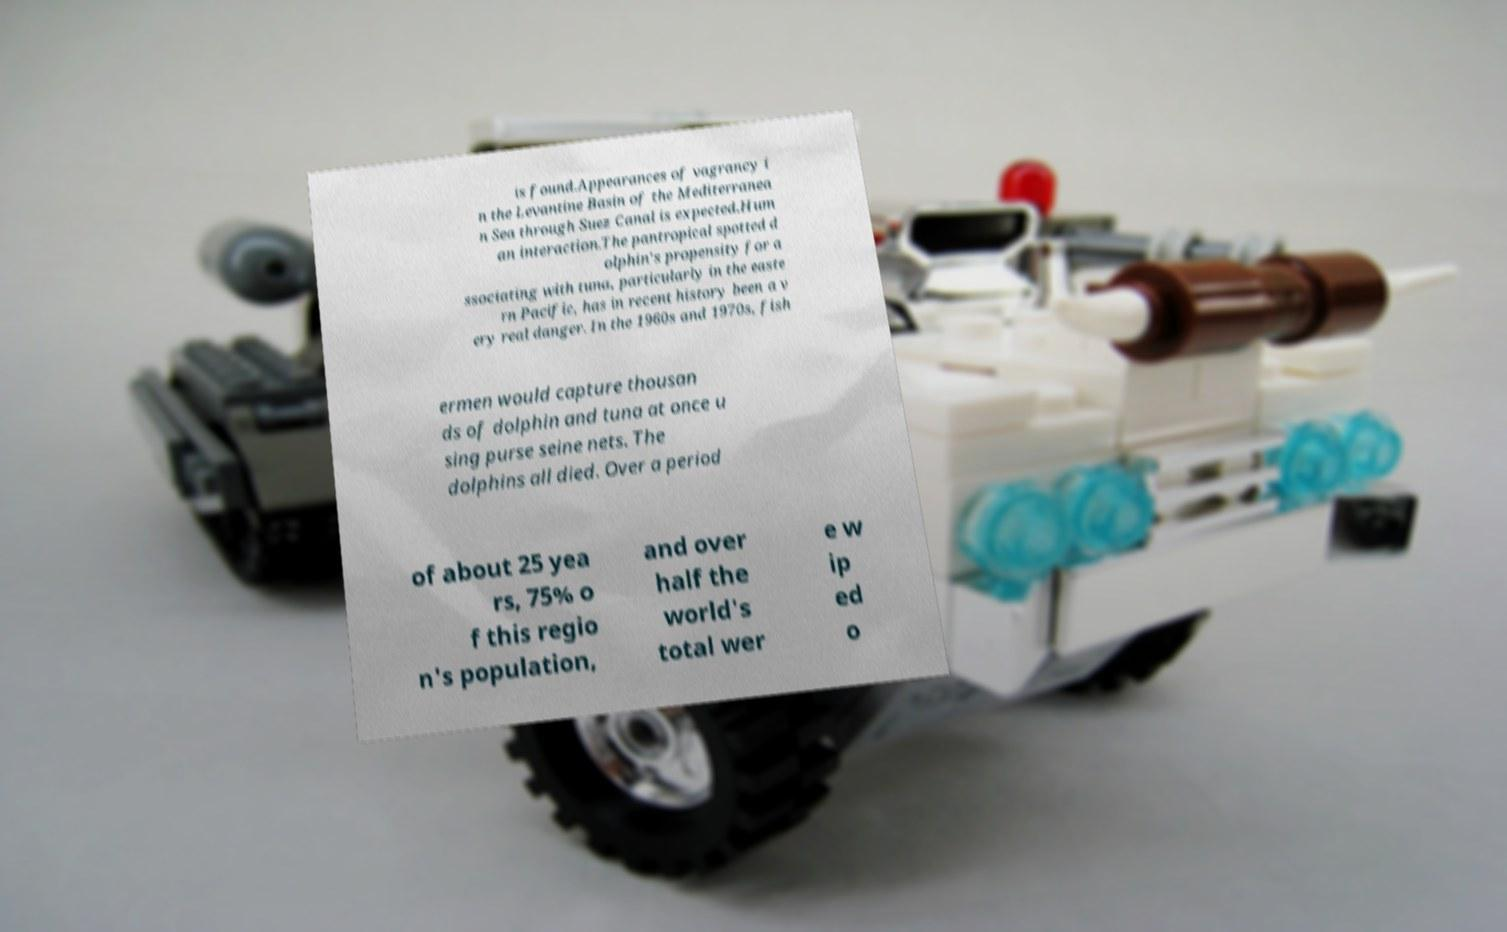Can you read and provide the text displayed in the image?This photo seems to have some interesting text. Can you extract and type it out for me? is found.Appearances of vagrancy i n the Levantine Basin of the Mediterranea n Sea through Suez Canal is expected.Hum an interaction.The pantropical spotted d olphin's propensity for a ssociating with tuna, particularly in the easte rn Pacific, has in recent history been a v ery real danger. In the 1960s and 1970s, fish ermen would capture thousan ds of dolphin and tuna at once u sing purse seine nets. The dolphins all died. Over a period of about 25 yea rs, 75% o f this regio n's population, and over half the world's total wer e w ip ed o 